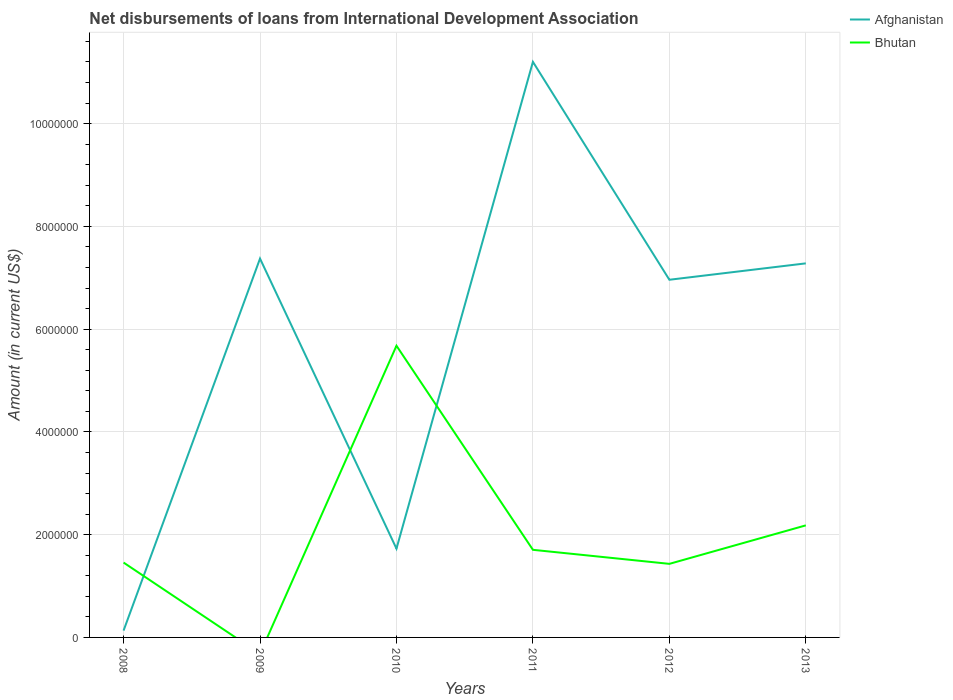Does the line corresponding to Bhutan intersect with the line corresponding to Afghanistan?
Offer a terse response. Yes. Is the number of lines equal to the number of legend labels?
Give a very brief answer. No. Across all years, what is the maximum amount of loans disbursed in Bhutan?
Offer a terse response. 0. What is the total amount of loans disbursed in Bhutan in the graph?
Make the answer very short. -7.49e+05. What is the difference between the highest and the second highest amount of loans disbursed in Bhutan?
Your response must be concise. 5.68e+06. Are the values on the major ticks of Y-axis written in scientific E-notation?
Offer a terse response. No. Does the graph contain any zero values?
Offer a very short reply. Yes. Where does the legend appear in the graph?
Your answer should be compact. Top right. What is the title of the graph?
Ensure brevity in your answer.  Net disbursements of loans from International Development Association. What is the label or title of the X-axis?
Keep it short and to the point. Years. What is the label or title of the Y-axis?
Offer a terse response. Amount (in current US$). What is the Amount (in current US$) in Afghanistan in 2008?
Give a very brief answer. 1.33e+05. What is the Amount (in current US$) in Bhutan in 2008?
Make the answer very short. 1.46e+06. What is the Amount (in current US$) in Afghanistan in 2009?
Offer a terse response. 7.37e+06. What is the Amount (in current US$) of Bhutan in 2009?
Give a very brief answer. 0. What is the Amount (in current US$) of Afghanistan in 2010?
Keep it short and to the point. 1.73e+06. What is the Amount (in current US$) of Bhutan in 2010?
Offer a very short reply. 5.68e+06. What is the Amount (in current US$) in Afghanistan in 2011?
Offer a terse response. 1.12e+07. What is the Amount (in current US$) of Bhutan in 2011?
Your answer should be compact. 1.70e+06. What is the Amount (in current US$) in Afghanistan in 2012?
Ensure brevity in your answer.  6.96e+06. What is the Amount (in current US$) in Bhutan in 2012?
Offer a very short reply. 1.43e+06. What is the Amount (in current US$) in Afghanistan in 2013?
Ensure brevity in your answer.  7.28e+06. What is the Amount (in current US$) in Bhutan in 2013?
Your answer should be very brief. 2.18e+06. Across all years, what is the maximum Amount (in current US$) in Afghanistan?
Keep it short and to the point. 1.12e+07. Across all years, what is the maximum Amount (in current US$) of Bhutan?
Your answer should be compact. 5.68e+06. Across all years, what is the minimum Amount (in current US$) of Afghanistan?
Your answer should be very brief. 1.33e+05. What is the total Amount (in current US$) in Afghanistan in the graph?
Make the answer very short. 3.47e+07. What is the total Amount (in current US$) in Bhutan in the graph?
Make the answer very short. 1.25e+07. What is the difference between the Amount (in current US$) in Afghanistan in 2008 and that in 2009?
Your answer should be very brief. -7.24e+06. What is the difference between the Amount (in current US$) in Afghanistan in 2008 and that in 2010?
Make the answer very short. -1.60e+06. What is the difference between the Amount (in current US$) in Bhutan in 2008 and that in 2010?
Give a very brief answer. -4.22e+06. What is the difference between the Amount (in current US$) of Afghanistan in 2008 and that in 2011?
Ensure brevity in your answer.  -1.11e+07. What is the difference between the Amount (in current US$) of Bhutan in 2008 and that in 2011?
Make the answer very short. -2.48e+05. What is the difference between the Amount (in current US$) of Afghanistan in 2008 and that in 2012?
Provide a short and direct response. -6.83e+06. What is the difference between the Amount (in current US$) in Bhutan in 2008 and that in 2012?
Your response must be concise. 2.50e+04. What is the difference between the Amount (in current US$) in Afghanistan in 2008 and that in 2013?
Ensure brevity in your answer.  -7.15e+06. What is the difference between the Amount (in current US$) in Bhutan in 2008 and that in 2013?
Offer a very short reply. -7.24e+05. What is the difference between the Amount (in current US$) of Afghanistan in 2009 and that in 2010?
Provide a short and direct response. 5.64e+06. What is the difference between the Amount (in current US$) of Afghanistan in 2009 and that in 2011?
Provide a short and direct response. -3.83e+06. What is the difference between the Amount (in current US$) of Afghanistan in 2009 and that in 2012?
Ensure brevity in your answer.  4.12e+05. What is the difference between the Amount (in current US$) of Afghanistan in 2009 and that in 2013?
Provide a succinct answer. 9.30e+04. What is the difference between the Amount (in current US$) in Afghanistan in 2010 and that in 2011?
Ensure brevity in your answer.  -9.47e+06. What is the difference between the Amount (in current US$) of Bhutan in 2010 and that in 2011?
Provide a short and direct response. 3.97e+06. What is the difference between the Amount (in current US$) in Afghanistan in 2010 and that in 2012?
Offer a very short reply. -5.23e+06. What is the difference between the Amount (in current US$) in Bhutan in 2010 and that in 2012?
Offer a very short reply. 4.24e+06. What is the difference between the Amount (in current US$) of Afghanistan in 2010 and that in 2013?
Offer a terse response. -5.55e+06. What is the difference between the Amount (in current US$) in Bhutan in 2010 and that in 2013?
Give a very brief answer. 3.50e+06. What is the difference between the Amount (in current US$) of Afghanistan in 2011 and that in 2012?
Keep it short and to the point. 4.24e+06. What is the difference between the Amount (in current US$) in Bhutan in 2011 and that in 2012?
Provide a short and direct response. 2.73e+05. What is the difference between the Amount (in current US$) of Afghanistan in 2011 and that in 2013?
Ensure brevity in your answer.  3.92e+06. What is the difference between the Amount (in current US$) in Bhutan in 2011 and that in 2013?
Ensure brevity in your answer.  -4.76e+05. What is the difference between the Amount (in current US$) in Afghanistan in 2012 and that in 2013?
Provide a short and direct response. -3.19e+05. What is the difference between the Amount (in current US$) of Bhutan in 2012 and that in 2013?
Offer a very short reply. -7.49e+05. What is the difference between the Amount (in current US$) of Afghanistan in 2008 and the Amount (in current US$) of Bhutan in 2010?
Offer a terse response. -5.54e+06. What is the difference between the Amount (in current US$) of Afghanistan in 2008 and the Amount (in current US$) of Bhutan in 2011?
Offer a terse response. -1.57e+06. What is the difference between the Amount (in current US$) of Afghanistan in 2008 and the Amount (in current US$) of Bhutan in 2012?
Your answer should be compact. -1.30e+06. What is the difference between the Amount (in current US$) of Afghanistan in 2008 and the Amount (in current US$) of Bhutan in 2013?
Provide a succinct answer. -2.05e+06. What is the difference between the Amount (in current US$) of Afghanistan in 2009 and the Amount (in current US$) of Bhutan in 2010?
Your answer should be very brief. 1.70e+06. What is the difference between the Amount (in current US$) in Afghanistan in 2009 and the Amount (in current US$) in Bhutan in 2011?
Make the answer very short. 5.67e+06. What is the difference between the Amount (in current US$) in Afghanistan in 2009 and the Amount (in current US$) in Bhutan in 2012?
Your answer should be very brief. 5.94e+06. What is the difference between the Amount (in current US$) of Afghanistan in 2009 and the Amount (in current US$) of Bhutan in 2013?
Provide a succinct answer. 5.19e+06. What is the difference between the Amount (in current US$) in Afghanistan in 2010 and the Amount (in current US$) in Bhutan in 2011?
Make the answer very short. 2.30e+04. What is the difference between the Amount (in current US$) of Afghanistan in 2010 and the Amount (in current US$) of Bhutan in 2012?
Provide a short and direct response. 2.96e+05. What is the difference between the Amount (in current US$) in Afghanistan in 2010 and the Amount (in current US$) in Bhutan in 2013?
Your answer should be compact. -4.53e+05. What is the difference between the Amount (in current US$) of Afghanistan in 2011 and the Amount (in current US$) of Bhutan in 2012?
Keep it short and to the point. 9.77e+06. What is the difference between the Amount (in current US$) of Afghanistan in 2011 and the Amount (in current US$) of Bhutan in 2013?
Keep it short and to the point. 9.02e+06. What is the difference between the Amount (in current US$) in Afghanistan in 2012 and the Amount (in current US$) in Bhutan in 2013?
Offer a terse response. 4.78e+06. What is the average Amount (in current US$) in Afghanistan per year?
Make the answer very short. 5.78e+06. What is the average Amount (in current US$) of Bhutan per year?
Your answer should be compact. 2.08e+06. In the year 2008, what is the difference between the Amount (in current US$) of Afghanistan and Amount (in current US$) of Bhutan?
Make the answer very short. -1.32e+06. In the year 2010, what is the difference between the Amount (in current US$) in Afghanistan and Amount (in current US$) in Bhutan?
Offer a very short reply. -3.95e+06. In the year 2011, what is the difference between the Amount (in current US$) of Afghanistan and Amount (in current US$) of Bhutan?
Your answer should be very brief. 9.50e+06. In the year 2012, what is the difference between the Amount (in current US$) in Afghanistan and Amount (in current US$) in Bhutan?
Make the answer very short. 5.53e+06. In the year 2013, what is the difference between the Amount (in current US$) in Afghanistan and Amount (in current US$) in Bhutan?
Provide a succinct answer. 5.10e+06. What is the ratio of the Amount (in current US$) of Afghanistan in 2008 to that in 2009?
Offer a very short reply. 0.02. What is the ratio of the Amount (in current US$) of Afghanistan in 2008 to that in 2010?
Provide a succinct answer. 0.08. What is the ratio of the Amount (in current US$) of Bhutan in 2008 to that in 2010?
Make the answer very short. 0.26. What is the ratio of the Amount (in current US$) of Afghanistan in 2008 to that in 2011?
Offer a very short reply. 0.01. What is the ratio of the Amount (in current US$) in Bhutan in 2008 to that in 2011?
Give a very brief answer. 0.85. What is the ratio of the Amount (in current US$) of Afghanistan in 2008 to that in 2012?
Provide a short and direct response. 0.02. What is the ratio of the Amount (in current US$) in Bhutan in 2008 to that in 2012?
Offer a very short reply. 1.02. What is the ratio of the Amount (in current US$) of Afghanistan in 2008 to that in 2013?
Your answer should be very brief. 0.02. What is the ratio of the Amount (in current US$) of Bhutan in 2008 to that in 2013?
Provide a short and direct response. 0.67. What is the ratio of the Amount (in current US$) of Afghanistan in 2009 to that in 2010?
Provide a short and direct response. 4.27. What is the ratio of the Amount (in current US$) of Afghanistan in 2009 to that in 2011?
Offer a terse response. 0.66. What is the ratio of the Amount (in current US$) in Afghanistan in 2009 to that in 2012?
Give a very brief answer. 1.06. What is the ratio of the Amount (in current US$) of Afghanistan in 2009 to that in 2013?
Provide a short and direct response. 1.01. What is the ratio of the Amount (in current US$) of Afghanistan in 2010 to that in 2011?
Offer a very short reply. 0.15. What is the ratio of the Amount (in current US$) of Bhutan in 2010 to that in 2011?
Ensure brevity in your answer.  3.33. What is the ratio of the Amount (in current US$) of Afghanistan in 2010 to that in 2012?
Give a very brief answer. 0.25. What is the ratio of the Amount (in current US$) of Bhutan in 2010 to that in 2012?
Offer a terse response. 3.96. What is the ratio of the Amount (in current US$) in Afghanistan in 2010 to that in 2013?
Your response must be concise. 0.24. What is the ratio of the Amount (in current US$) of Bhutan in 2010 to that in 2013?
Ensure brevity in your answer.  2.6. What is the ratio of the Amount (in current US$) of Afghanistan in 2011 to that in 2012?
Offer a terse response. 1.61. What is the ratio of the Amount (in current US$) in Bhutan in 2011 to that in 2012?
Give a very brief answer. 1.19. What is the ratio of the Amount (in current US$) in Afghanistan in 2011 to that in 2013?
Provide a succinct answer. 1.54. What is the ratio of the Amount (in current US$) in Bhutan in 2011 to that in 2013?
Offer a very short reply. 0.78. What is the ratio of the Amount (in current US$) in Afghanistan in 2012 to that in 2013?
Provide a short and direct response. 0.96. What is the ratio of the Amount (in current US$) of Bhutan in 2012 to that in 2013?
Offer a terse response. 0.66. What is the difference between the highest and the second highest Amount (in current US$) of Afghanistan?
Your response must be concise. 3.83e+06. What is the difference between the highest and the second highest Amount (in current US$) of Bhutan?
Keep it short and to the point. 3.50e+06. What is the difference between the highest and the lowest Amount (in current US$) in Afghanistan?
Provide a short and direct response. 1.11e+07. What is the difference between the highest and the lowest Amount (in current US$) in Bhutan?
Offer a very short reply. 5.68e+06. 